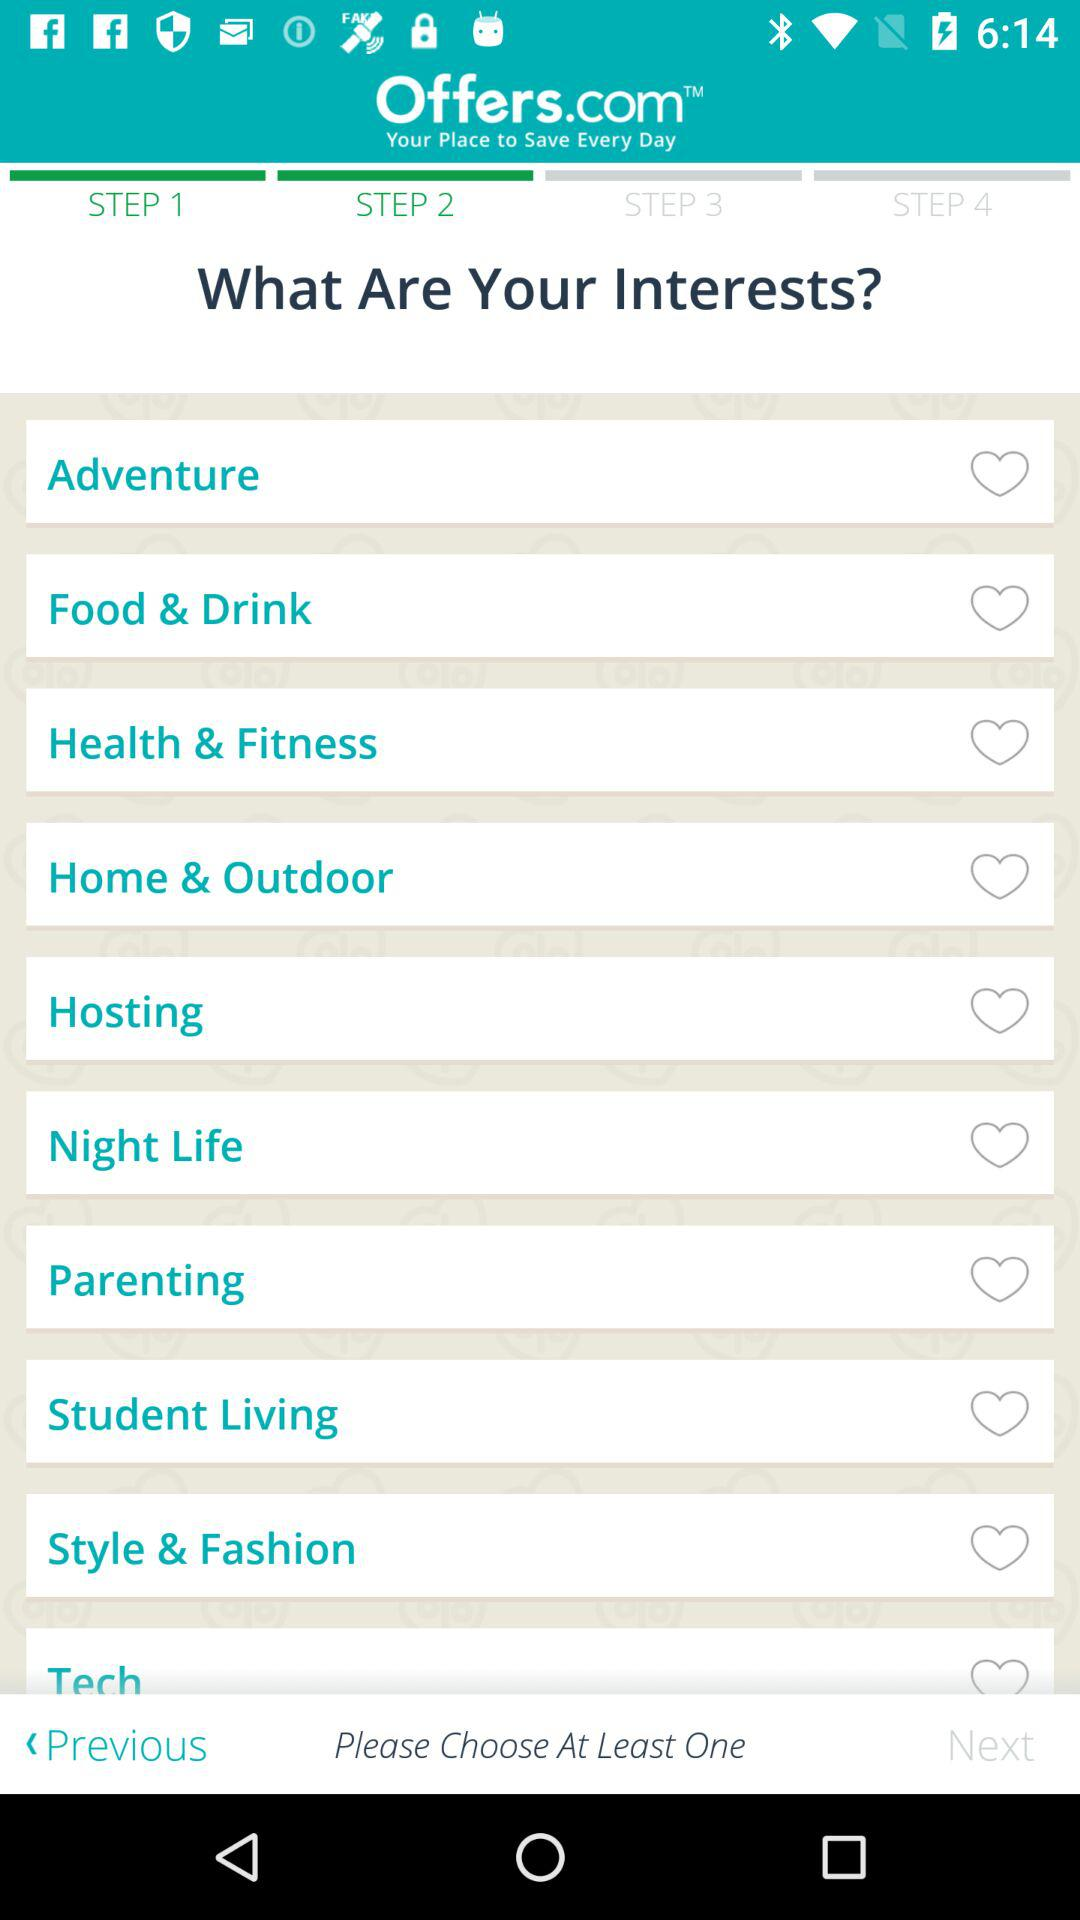How many interests are there in total?
Answer the question using a single word or phrase. 10 